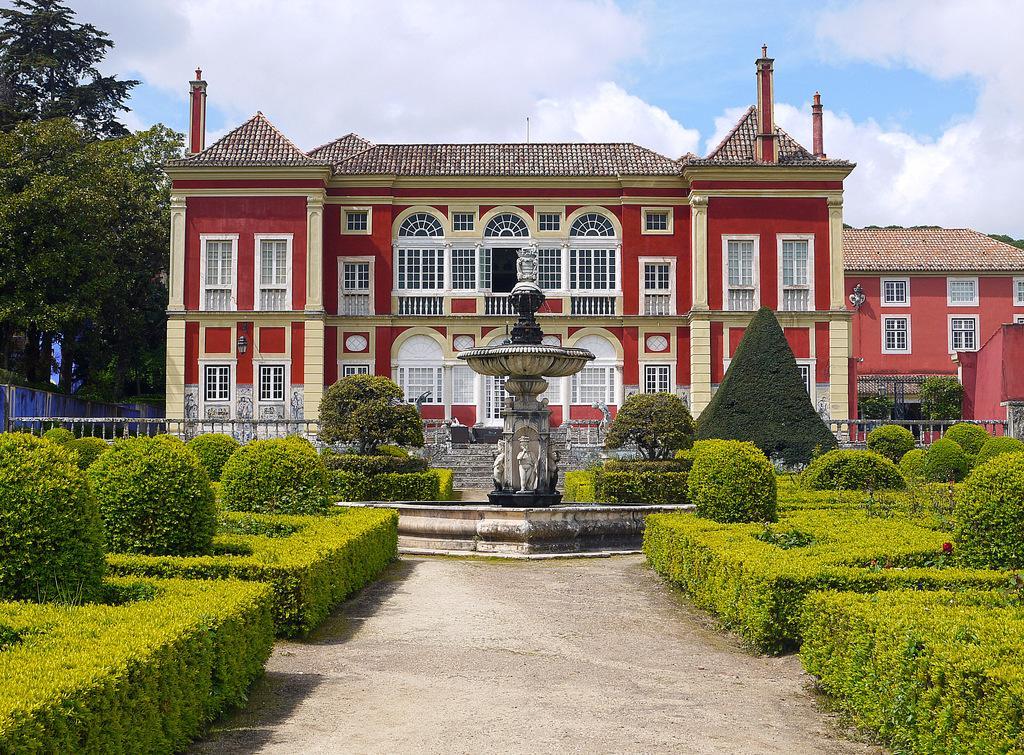How would you summarize this image in a sentence or two? There is a mountain and plants are present at the bottom of this image. We can see buildings and trees in the middle of this image. The cloudy sky is in the background of this image. 